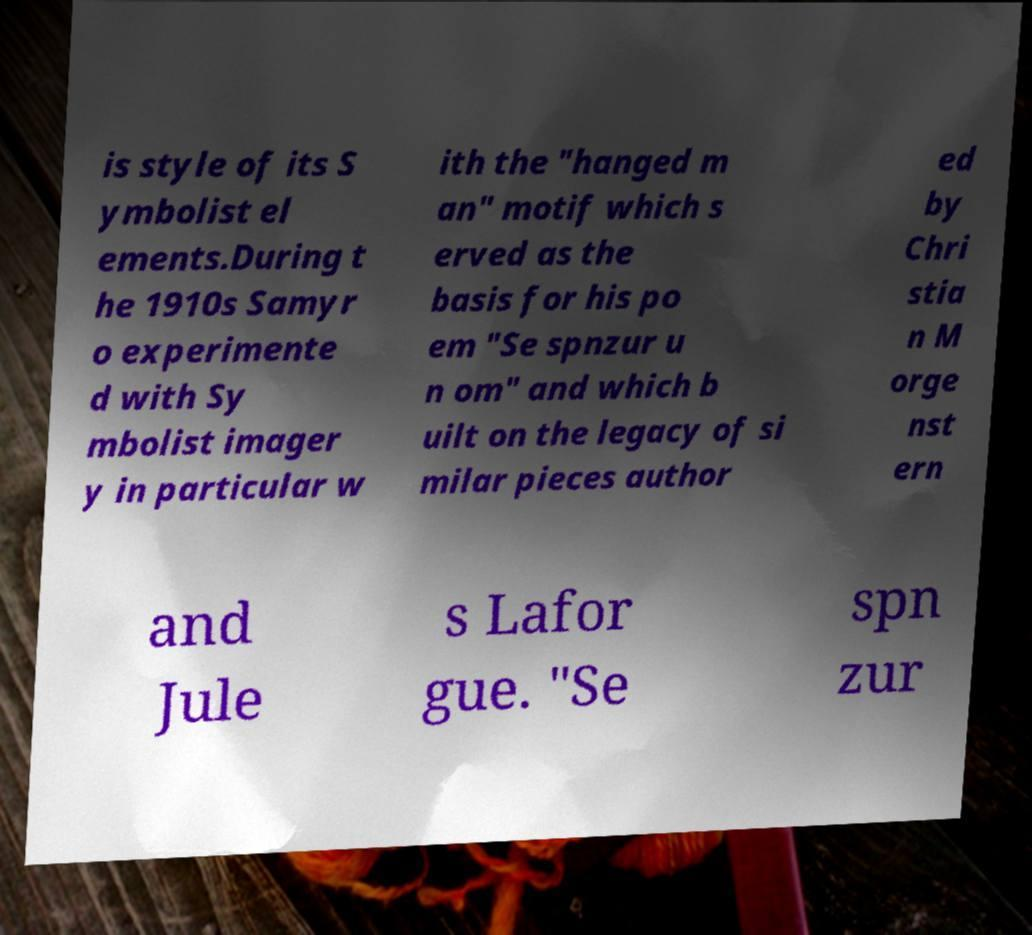For documentation purposes, I need the text within this image transcribed. Could you provide that? is style of its S ymbolist el ements.During t he 1910s Samyr o experimente d with Sy mbolist imager y in particular w ith the "hanged m an" motif which s erved as the basis for his po em "Se spnzur u n om" and which b uilt on the legacy of si milar pieces author ed by Chri stia n M orge nst ern and Jule s Lafor gue. "Se spn zur 